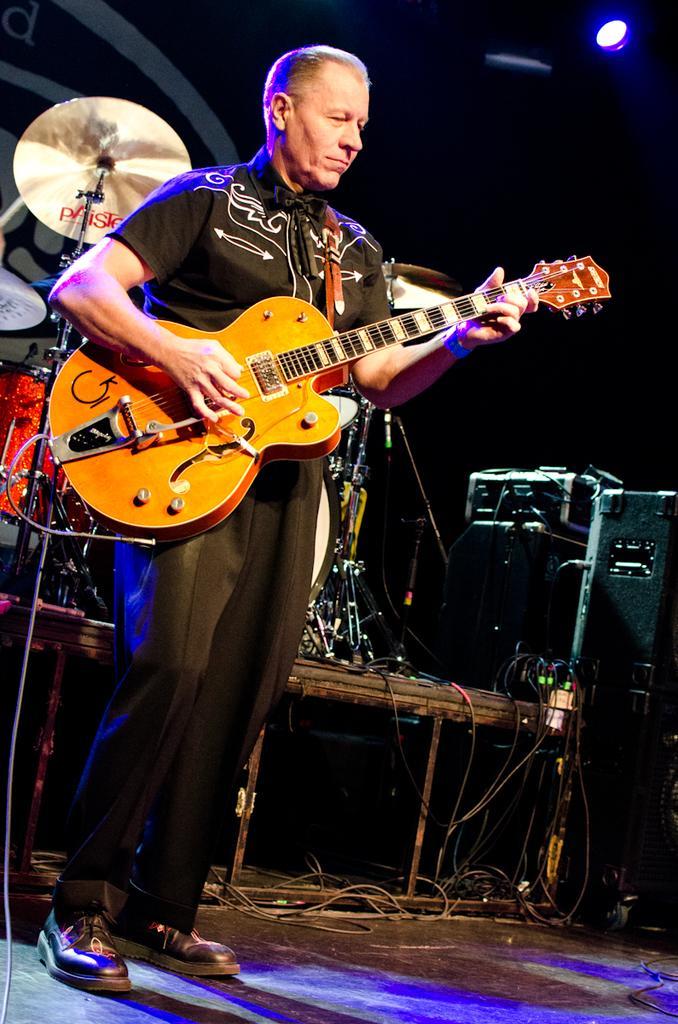Please provide a concise description of this image. Here we can see a man playing a guitar and behind him we can see drums and other musical instruments 